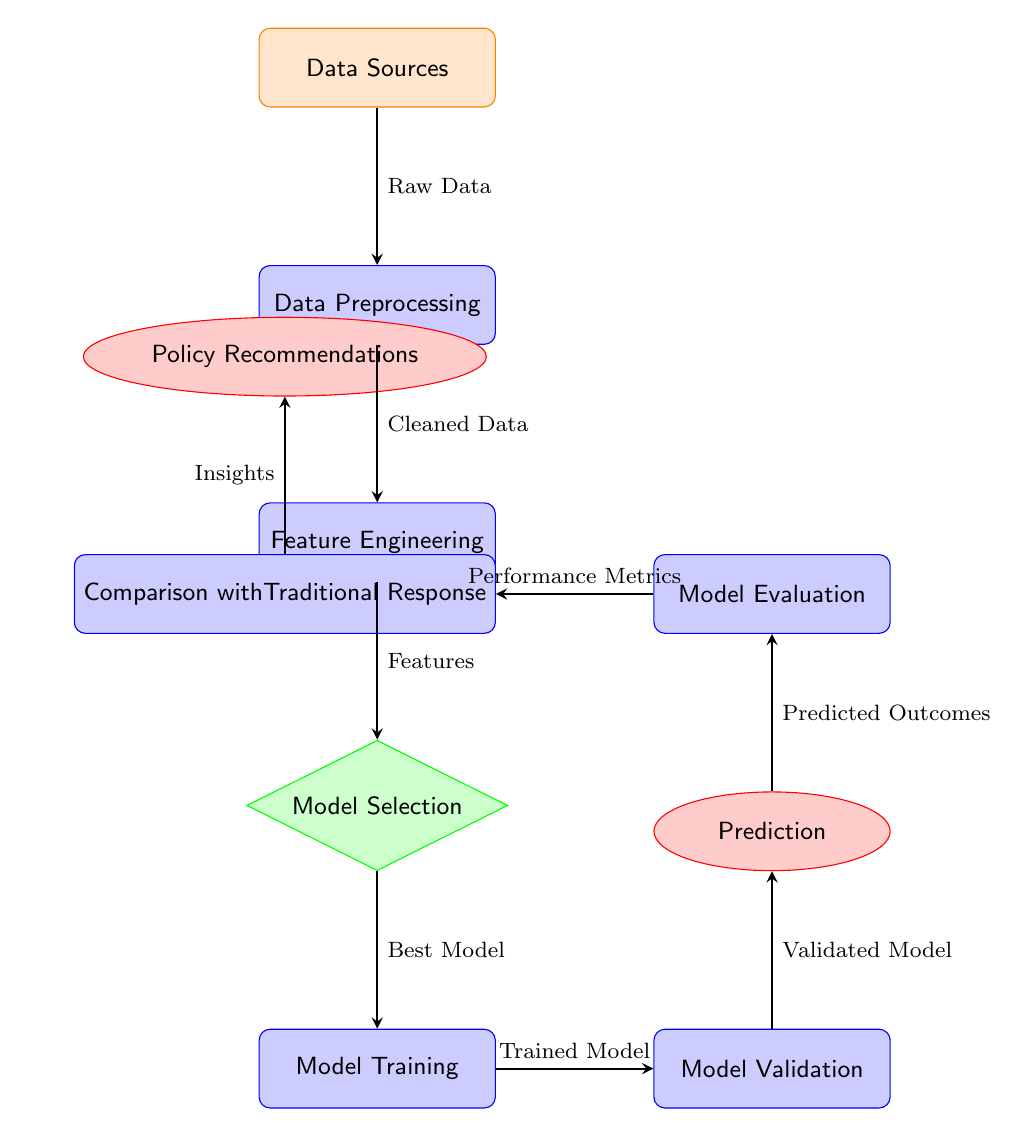What are the data sources in this diagram? The first node labeled "Data Sources" identifies where all raw data originates. This node is crucial as it serves as the starting point of the flowchart, and there are no specific examples given in the diagram.
Answer: Data Sources How many processes are depicted in the diagram? Counting all rectangles representing processes, we identify them as "Data Preprocessing," "Feature Engineering," "Model Training," "Model Validation," "Prediction," "Model Evaluation," and "Comparison with Traditional Response." This sums up to a total of six processes in the diagram.
Answer: 6 What is the output of the "Model Evaluation" process? The next node above "Model Evaluation" is labeled "Performance Metrics," which is the output resulting from evaluating the model's performance, indicating how well it has been trained and validated.
Answer: Performance Metrics Which process follows "Model Selection"? Following the flow from "Model Selection," the next process indicated in the diagram is "Model Training." This shows the order in which actions are taken, where the model identified during selection is then trained.
Answer: Model Training What kind of recommendations does the last output node generate? The very last output is labeled "Policy Recommendations." This suggests that the insights and analysis from the previous processes culminate in actionable recommendations regarding policy changes or improvements, specifically regarding emergency response models.
Answer: Policy Recommendations What information flows into the "Feature Engineering" process? The flow leading into "Feature Engineering" is labeled "Cleaned Data," which suggests that this processed input data is what is used for extracting relevant features essential for building a predictive model, thus maintaining logical continuity.
Answer: Cleaned Data What are the outputs of the "Prediction" process? The node above "Prediction" describes it produces "Predicted Outcomes." The term here indicates that this step uses the validated model to generate predictions based on input data, leading to informed outputs relevant to the situation being analyzed.
Answer: Predicted Outcomes 